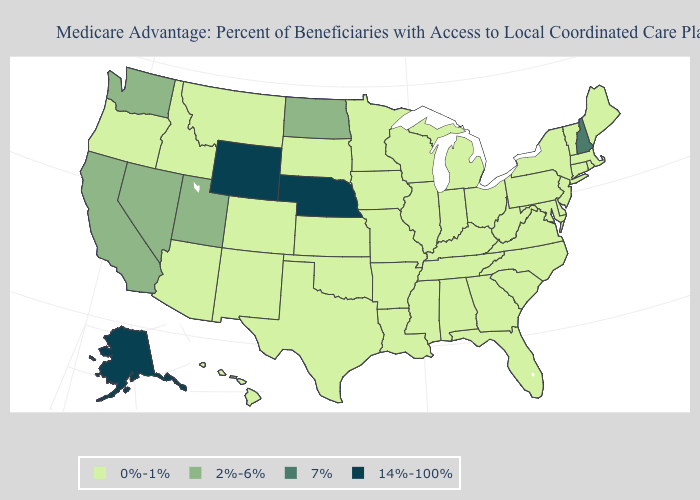Among the states that border Virginia , which have the highest value?
Quick response, please. Kentucky, Maryland, North Carolina, Tennessee, West Virginia. Which states hav the highest value in the West?
Be succinct. Alaska, Wyoming. Does Vermont have a higher value than South Dakota?
Write a very short answer. No. What is the value of Idaho?
Keep it brief. 0%-1%. What is the value of Maryland?
Give a very brief answer. 0%-1%. Does Maryland have a lower value than Alaska?
Short answer required. Yes. What is the lowest value in the Northeast?
Answer briefly. 0%-1%. What is the highest value in the Northeast ?
Write a very short answer. 7%. What is the value of New Mexico?
Quick response, please. 0%-1%. Among the states that border Delaware , which have the highest value?
Quick response, please. Maryland, New Jersey, Pennsylvania. Name the states that have a value in the range 2%-6%?
Be succinct. California, North Dakota, Nevada, Utah, Washington. What is the lowest value in the USA?
Quick response, please. 0%-1%. What is the value of Hawaii?
Be succinct. 0%-1%. 